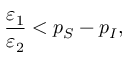<formula> <loc_0><loc_0><loc_500><loc_500>\frac { \varepsilon _ { 1 } } { \varepsilon _ { 2 } } < p _ { S } - p _ { I } ,</formula> 